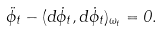Convert formula to latex. <formula><loc_0><loc_0><loc_500><loc_500>\ddot { \phi } _ { t } - ( d \dot { \phi } _ { t } , d \dot { \phi } _ { t } ) _ { \omega _ { t } } = 0 .</formula> 